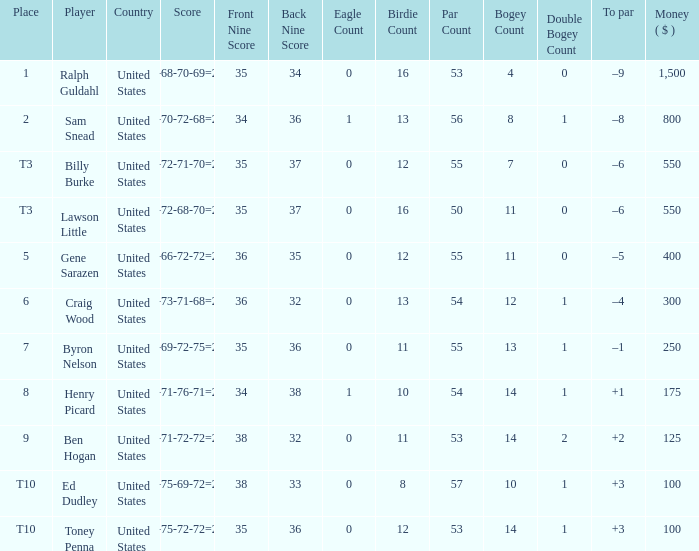Which score has a prize of $400? 73-66-72-72=283. 